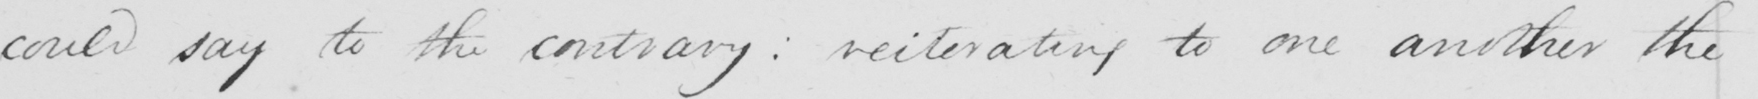Can you read and transcribe this handwriting? could say to the contrary reiterating to one another the 